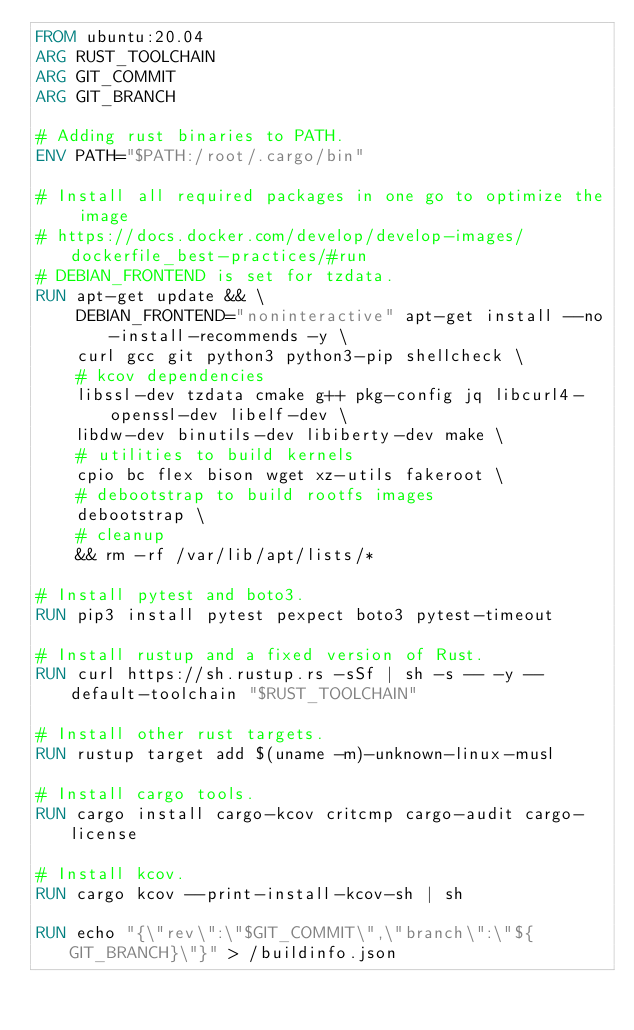Convert code to text. <code><loc_0><loc_0><loc_500><loc_500><_Dockerfile_>FROM ubuntu:20.04
ARG RUST_TOOLCHAIN
ARG GIT_COMMIT
ARG GIT_BRANCH

# Adding rust binaries to PATH.
ENV PATH="$PATH:/root/.cargo/bin"

# Install all required packages in one go to optimize the image
# https://docs.docker.com/develop/develop-images/dockerfile_best-practices/#run
# DEBIAN_FRONTEND is set for tzdata.
RUN apt-get update && \
    DEBIAN_FRONTEND="noninteractive" apt-get install --no-install-recommends -y \
    curl gcc git python3 python3-pip shellcheck \
    # kcov dependencies
    libssl-dev tzdata cmake g++ pkg-config jq libcurl4-openssl-dev libelf-dev \
    libdw-dev binutils-dev libiberty-dev make \
    # utilities to build kernels
    cpio bc flex bison wget xz-utils fakeroot \
    # debootstrap to build rootfs images
    debootstrap \
    # cleanup
    && rm -rf /var/lib/apt/lists/*

# Install pytest and boto3.
RUN pip3 install pytest pexpect boto3 pytest-timeout

# Install rustup and a fixed version of Rust.
RUN curl https://sh.rustup.rs -sSf | sh -s -- -y --default-toolchain "$RUST_TOOLCHAIN"

# Install other rust targets.
RUN rustup target add $(uname -m)-unknown-linux-musl

# Install cargo tools.
RUN cargo install cargo-kcov critcmp cargo-audit cargo-license

# Install kcov.
RUN cargo kcov --print-install-kcov-sh | sh

RUN echo "{\"rev\":\"$GIT_COMMIT\",\"branch\":\"${GIT_BRANCH}\"}" > /buildinfo.json
</code> 